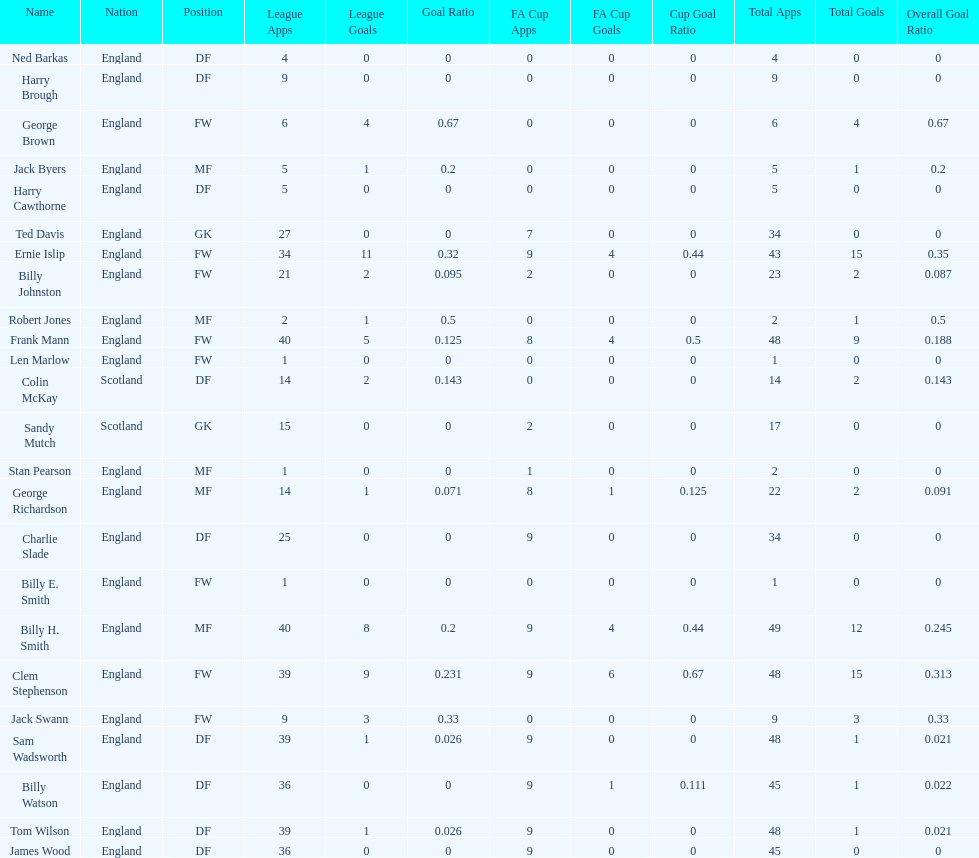What are the number of league apps ted davis has? 27. 